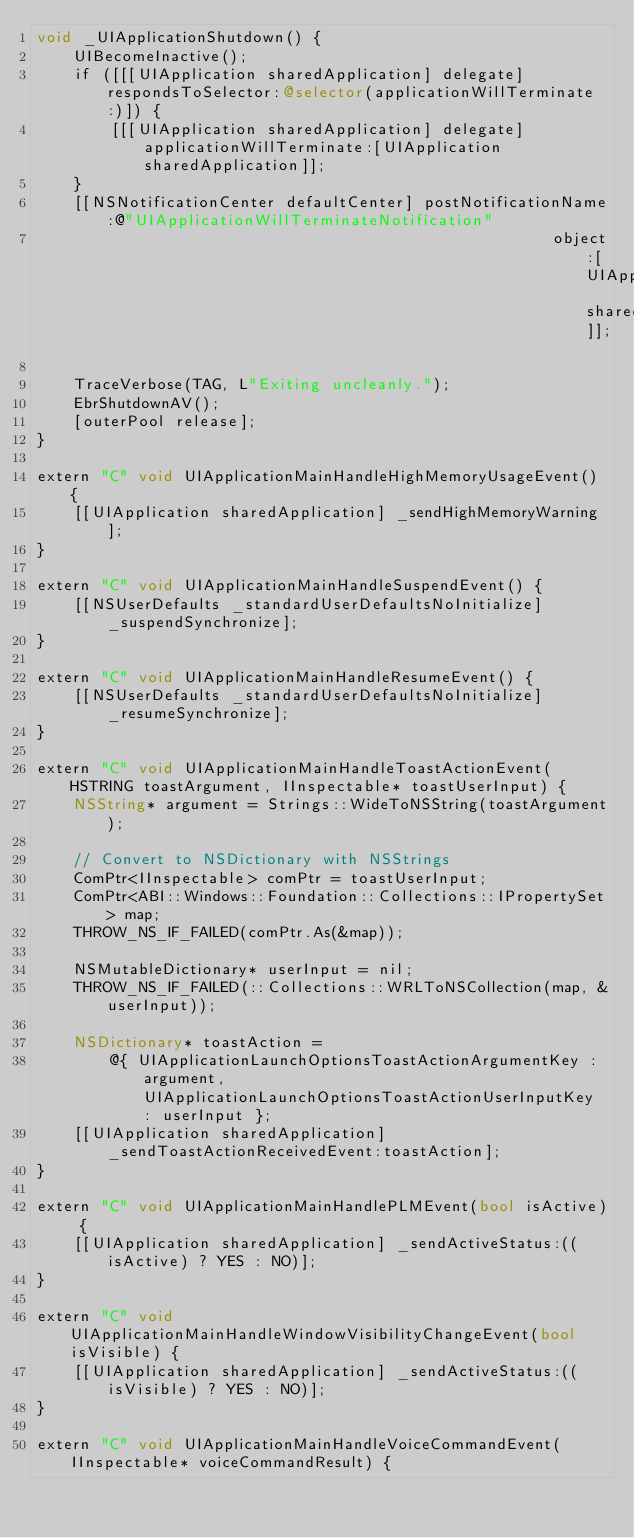Convert code to text. <code><loc_0><loc_0><loc_500><loc_500><_ObjectiveC_>void _UIApplicationShutdown() {
    UIBecomeInactive();
    if ([[[UIApplication sharedApplication] delegate] respondsToSelector:@selector(applicationWillTerminate:)]) {
        [[[UIApplication sharedApplication] delegate] applicationWillTerminate:[UIApplication sharedApplication]];
    }
    [[NSNotificationCenter defaultCenter] postNotificationName:@"UIApplicationWillTerminateNotification"
                                                        object:[UIApplication sharedApplication]];

    TraceVerbose(TAG, L"Exiting uncleanly.");
    EbrShutdownAV();
    [outerPool release];
}

extern "C" void UIApplicationMainHandleHighMemoryUsageEvent() {
    [[UIApplication sharedApplication] _sendHighMemoryWarning];
}

extern "C" void UIApplicationMainHandleSuspendEvent() {
    [[NSUserDefaults _standardUserDefaultsNoInitialize] _suspendSynchronize];
}

extern "C" void UIApplicationMainHandleResumeEvent() {
    [[NSUserDefaults _standardUserDefaultsNoInitialize] _resumeSynchronize];
}

extern "C" void UIApplicationMainHandleToastActionEvent(HSTRING toastArgument, IInspectable* toastUserInput) {
    NSString* argument = Strings::WideToNSString(toastArgument);

    // Convert to NSDictionary with NSStrings
    ComPtr<IInspectable> comPtr = toastUserInput;
    ComPtr<ABI::Windows::Foundation::Collections::IPropertySet> map;
    THROW_NS_IF_FAILED(comPtr.As(&map));

    NSMutableDictionary* userInput = nil;
    THROW_NS_IF_FAILED(::Collections::WRLToNSCollection(map, &userInput));

    NSDictionary* toastAction =
        @{ UIApplicationLaunchOptionsToastActionArgumentKey : argument, UIApplicationLaunchOptionsToastActionUserInputKey : userInput };
    [[UIApplication sharedApplication] _sendToastActionReceivedEvent:toastAction];
}

extern "C" void UIApplicationMainHandlePLMEvent(bool isActive) {
    [[UIApplication sharedApplication] _sendActiveStatus:((isActive) ? YES : NO)];
}

extern "C" void UIApplicationMainHandleWindowVisibilityChangeEvent(bool isVisible) {
    [[UIApplication sharedApplication] _sendActiveStatus:((isVisible) ? YES : NO)];
}

extern "C" void UIApplicationMainHandleVoiceCommandEvent(IInspectable* voiceCommandResult) {</code> 